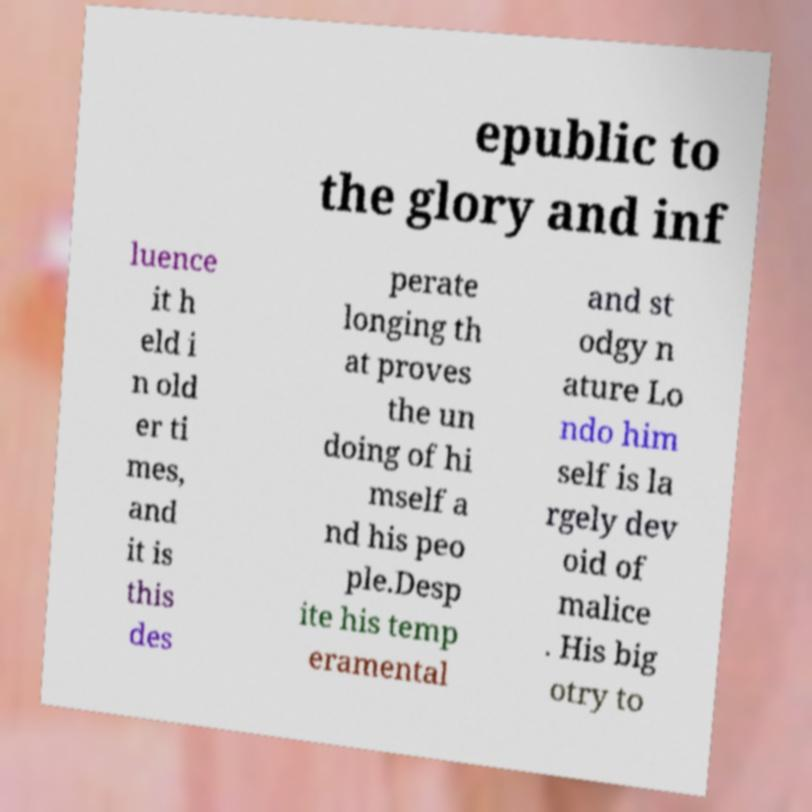Can you read and provide the text displayed in the image?This photo seems to have some interesting text. Can you extract and type it out for me? epublic to the glory and inf luence it h eld i n old er ti mes, and it is this des perate longing th at proves the un doing of hi mself a nd his peo ple.Desp ite his temp eramental and st odgy n ature Lo ndo him self is la rgely dev oid of malice . His big otry to 